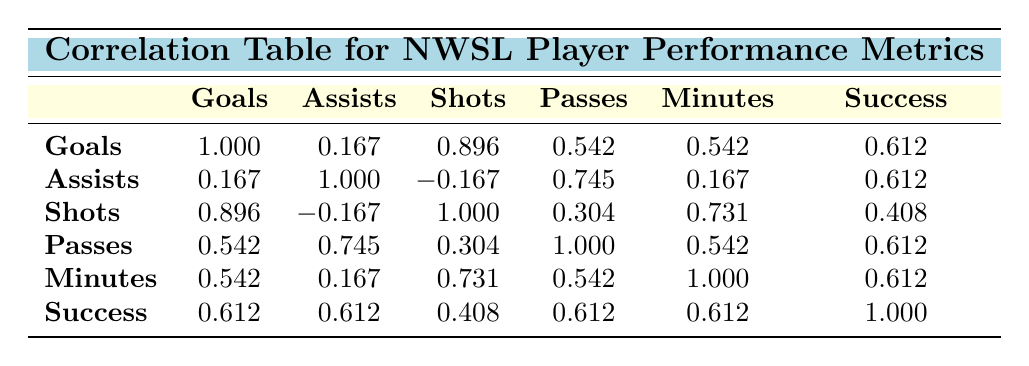What is the correlation between goals and team success? The correlation value between goals and team success is 0.612, indicating a moderate positive correlation. This suggests that players who score more goals are likely to be part of a team that is successful.
Answer: 0.612 What is the correlation between assists and shots taken? The correlation value between assists and shots taken is -0.167. This indicates a very weak negative correlation, suggesting that as one increases, the other does not necessarily follow a clear trend.
Answer: -0.167 Which performance metric has the highest correlation with team success? The correlations with team success are as follows: Goals (0.612), Assists (0.612), Shots (0.408), Passes (0.612), and Minutes (0.612). Since Goals, Assists, Passes, and Minutes have the same highest value of 0.612, they are all equally the highest correlated metrics with team success.
Answer: Goals, Assists, Passes, and Minutes (all 0.612) What is the average correlation between all player performance metrics and team success? To calculate the average correlation with team success, add up the correlation values: 0.612 (Goals) + 0.612 (Assists) + 0.408 (Shots) + 0.612 (Passes) + 0.612 (Minutes) = 2.862. Then divide by the total number of metrics (5): 2.862 / 5 = 0.5724 (rounded to 0.572).
Answer: 0.572 Is there a stronger correlation between goals or shots and team success? The correlation for Goals and team success is 0.612, while the correlation for Shots and team success is 0.408. Since 0.612 is greater than 0.408, goals have a stronger correlation with team success than shots do.
Answer: Yes, goals have a stronger correlation 